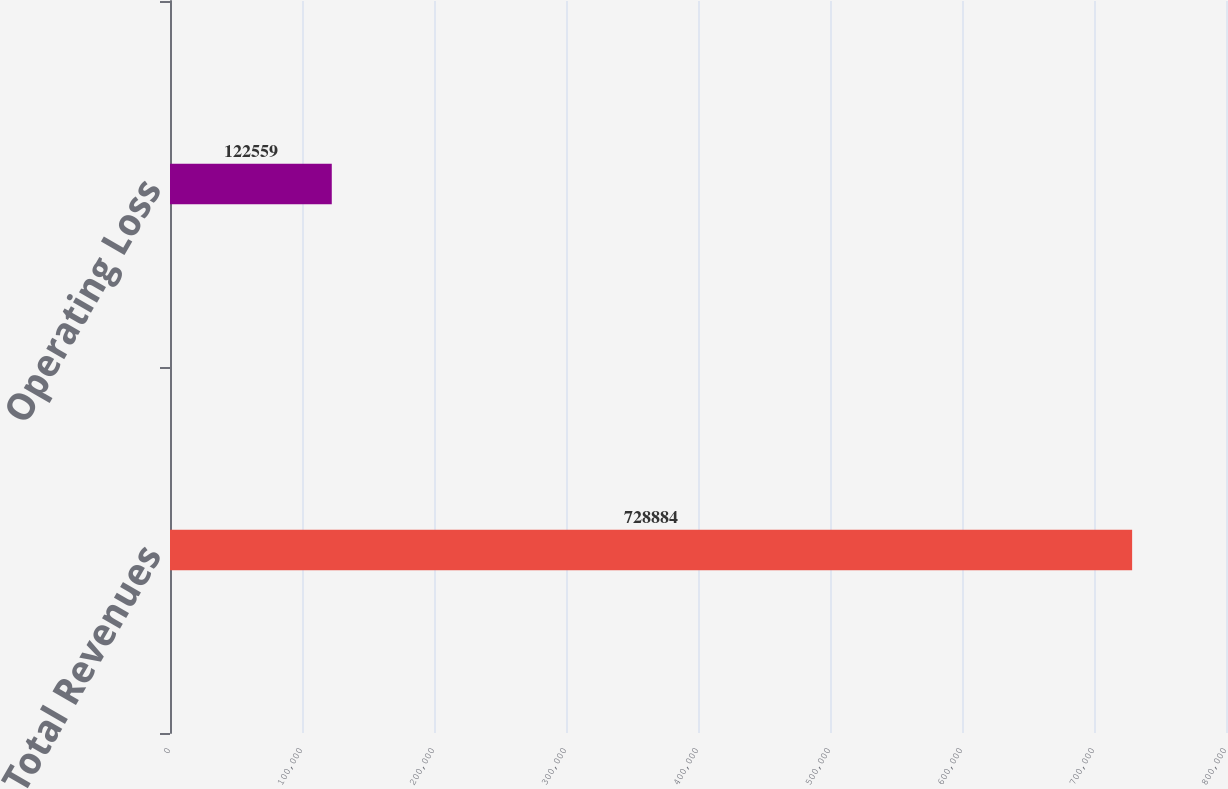<chart> <loc_0><loc_0><loc_500><loc_500><bar_chart><fcel>Total Revenues<fcel>Operating Loss<nl><fcel>728884<fcel>122559<nl></chart> 